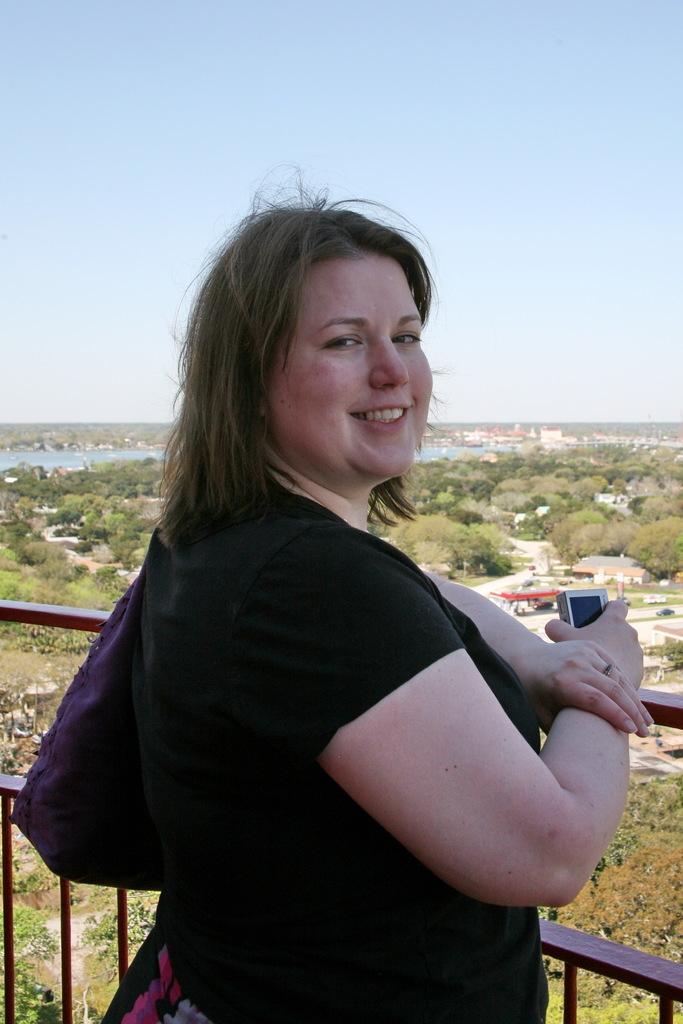How would you summarize this image in a sentence or two? In the center of the image we can see a lady standing and smiling. At the bottom we can see railings. In the background there are trees, buildings, hills and sky. We can see water. 